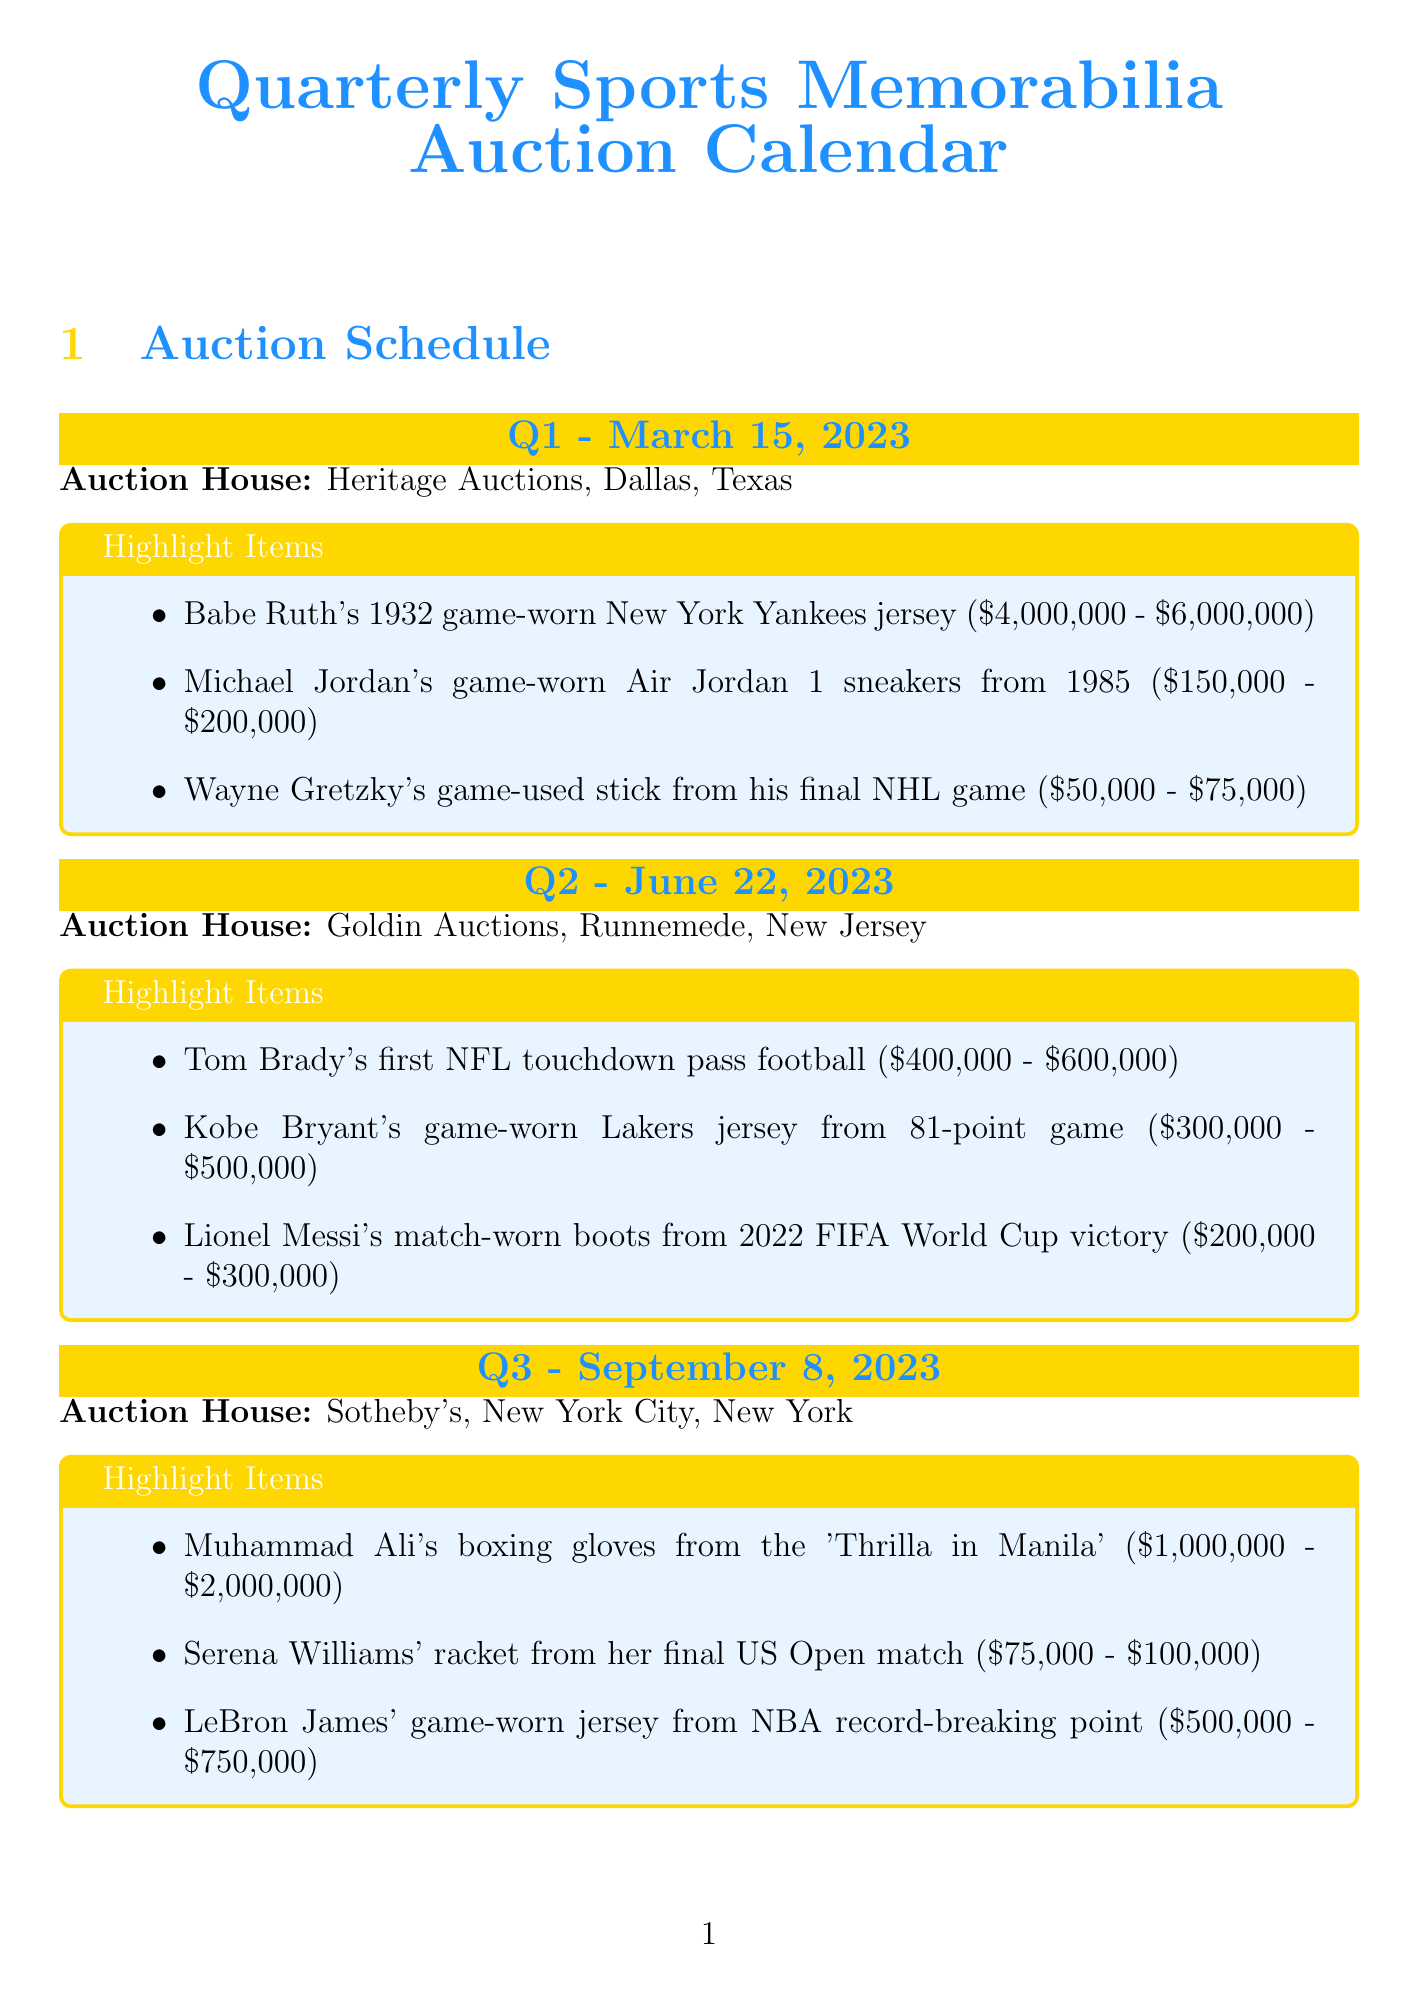What is the date of the Q1 auction? The date of the Q1 auction is March 15, 2023.
Answer: March 15, 2023 Which auction house is hosting the Q4 auction? The auction house hosting the Q4 auction is Christie's.
Answer: Christie's What is the estimated value range of Babe Ruth's jersey? The estimated value range of Babe Ruth's jersey is $4,000,000 - $6,000,000.
Answer: $4,000,000 - $6,000,000 How many highlight items are listed for Q3? The number of highlight items listed for Q3 is three.
Answer: three Which item has the highest estimated value in Q2? The item with the highest estimated value in Q2 is Kobe Bryant's game-worn jersey from his 81-point game.
Answer: Kobe Bryant's game-worn Lakers jersey from 81-point game What are the payment methods available for the auctions? The payment methods available for the auctions include credit card, wire transfer, and PayPal.
Answer: Credit card, Wire transfer, PayPal What is the annual fee for the Sports Collectors Club? The annual fee for the Sports Collectors Club is $999.
Answer: $999 How many weeks before each auction are the online preview dates? The online preview dates are two weeks before each auction.
Answer: two weeks 